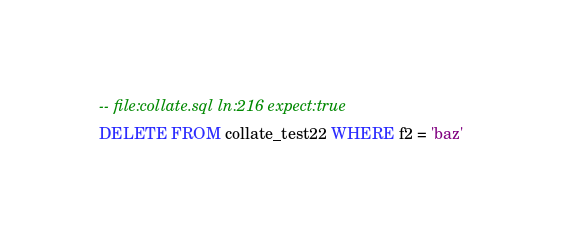<code> <loc_0><loc_0><loc_500><loc_500><_SQL_>-- file:collate.sql ln:216 expect:true
DELETE FROM collate_test22 WHERE f2 = 'baz'
</code> 